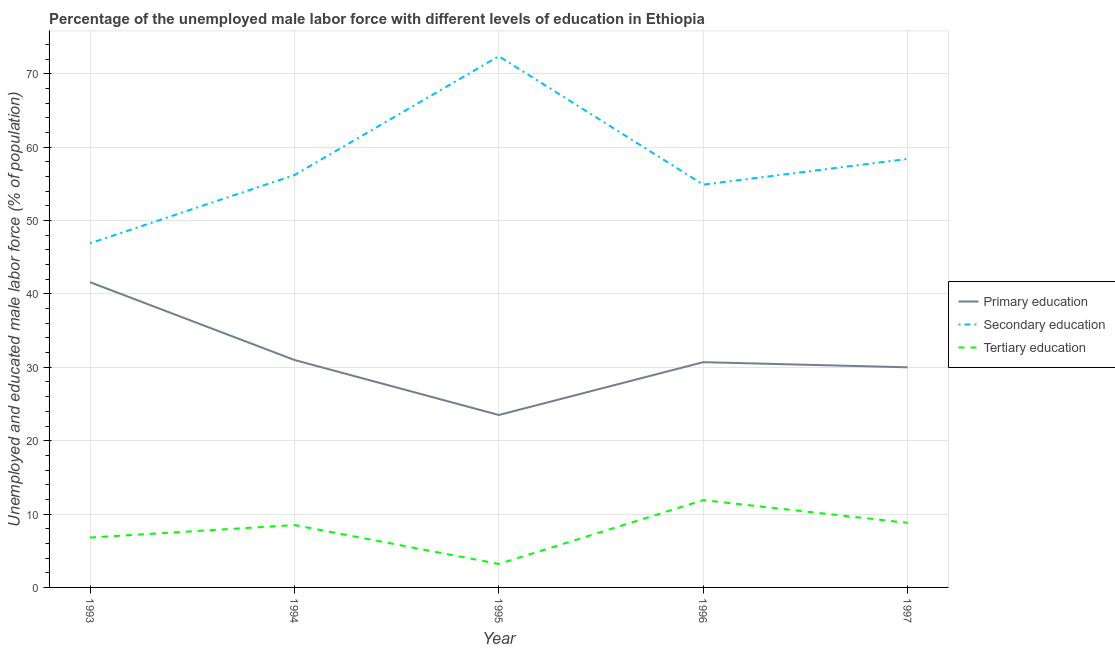Does the line corresponding to percentage of male labor force who received primary education intersect with the line corresponding to percentage of male labor force who received tertiary education?
Ensure brevity in your answer.  No. What is the percentage of male labor force who received secondary education in 1994?
Keep it short and to the point. 56.2. Across all years, what is the maximum percentage of male labor force who received primary education?
Give a very brief answer. 41.6. Across all years, what is the minimum percentage of male labor force who received tertiary education?
Provide a short and direct response. 3.2. In which year was the percentage of male labor force who received primary education maximum?
Give a very brief answer. 1993. What is the total percentage of male labor force who received primary education in the graph?
Keep it short and to the point. 156.8. What is the difference between the percentage of male labor force who received secondary education in 1995 and that in 1997?
Provide a short and direct response. 14. What is the difference between the percentage of male labor force who received primary education in 1997 and the percentage of male labor force who received tertiary education in 1996?
Your answer should be compact. 18.1. What is the average percentage of male labor force who received primary education per year?
Offer a very short reply. 31.36. In the year 1993, what is the difference between the percentage of male labor force who received tertiary education and percentage of male labor force who received secondary education?
Keep it short and to the point. -40.1. In how many years, is the percentage of male labor force who received tertiary education greater than 64 %?
Keep it short and to the point. 0. What is the ratio of the percentage of male labor force who received primary education in 1993 to that in 1996?
Provide a succinct answer. 1.36. Is the percentage of male labor force who received secondary education in 1996 less than that in 1997?
Your answer should be very brief. Yes. What is the difference between the highest and the second highest percentage of male labor force who received secondary education?
Make the answer very short. 14. What is the difference between the highest and the lowest percentage of male labor force who received tertiary education?
Offer a very short reply. 8.7. Is the sum of the percentage of male labor force who received secondary education in 1995 and 1996 greater than the maximum percentage of male labor force who received tertiary education across all years?
Give a very brief answer. Yes. Is the percentage of male labor force who received secondary education strictly greater than the percentage of male labor force who received tertiary education over the years?
Offer a terse response. Yes. Is the percentage of male labor force who received tertiary education strictly less than the percentage of male labor force who received secondary education over the years?
Offer a terse response. Yes. How many lines are there?
Keep it short and to the point. 3. What is the difference between two consecutive major ticks on the Y-axis?
Your answer should be compact. 10. Are the values on the major ticks of Y-axis written in scientific E-notation?
Ensure brevity in your answer.  No. Does the graph contain grids?
Provide a short and direct response. Yes. What is the title of the graph?
Provide a short and direct response. Percentage of the unemployed male labor force with different levels of education in Ethiopia. What is the label or title of the X-axis?
Your answer should be very brief. Year. What is the label or title of the Y-axis?
Provide a succinct answer. Unemployed and educated male labor force (% of population). What is the Unemployed and educated male labor force (% of population) in Primary education in 1993?
Your answer should be compact. 41.6. What is the Unemployed and educated male labor force (% of population) in Secondary education in 1993?
Your response must be concise. 46.9. What is the Unemployed and educated male labor force (% of population) in Tertiary education in 1993?
Your answer should be very brief. 6.8. What is the Unemployed and educated male labor force (% of population) of Secondary education in 1994?
Your response must be concise. 56.2. What is the Unemployed and educated male labor force (% of population) in Secondary education in 1995?
Provide a succinct answer. 72.4. What is the Unemployed and educated male labor force (% of population) in Tertiary education in 1995?
Offer a very short reply. 3.2. What is the Unemployed and educated male labor force (% of population) in Primary education in 1996?
Provide a succinct answer. 30.7. What is the Unemployed and educated male labor force (% of population) in Secondary education in 1996?
Your answer should be compact. 54.9. What is the Unemployed and educated male labor force (% of population) of Tertiary education in 1996?
Your answer should be very brief. 11.9. What is the Unemployed and educated male labor force (% of population) in Primary education in 1997?
Your answer should be very brief. 30. What is the Unemployed and educated male labor force (% of population) of Secondary education in 1997?
Your response must be concise. 58.4. What is the Unemployed and educated male labor force (% of population) of Tertiary education in 1997?
Keep it short and to the point. 8.8. Across all years, what is the maximum Unemployed and educated male labor force (% of population) of Primary education?
Ensure brevity in your answer.  41.6. Across all years, what is the maximum Unemployed and educated male labor force (% of population) of Secondary education?
Your response must be concise. 72.4. Across all years, what is the maximum Unemployed and educated male labor force (% of population) of Tertiary education?
Keep it short and to the point. 11.9. Across all years, what is the minimum Unemployed and educated male labor force (% of population) in Secondary education?
Your answer should be very brief. 46.9. Across all years, what is the minimum Unemployed and educated male labor force (% of population) of Tertiary education?
Offer a very short reply. 3.2. What is the total Unemployed and educated male labor force (% of population) in Primary education in the graph?
Ensure brevity in your answer.  156.8. What is the total Unemployed and educated male labor force (% of population) of Secondary education in the graph?
Ensure brevity in your answer.  288.8. What is the total Unemployed and educated male labor force (% of population) in Tertiary education in the graph?
Offer a very short reply. 39.2. What is the difference between the Unemployed and educated male labor force (% of population) of Primary education in 1993 and that in 1994?
Keep it short and to the point. 10.6. What is the difference between the Unemployed and educated male labor force (% of population) of Secondary education in 1993 and that in 1995?
Provide a short and direct response. -25.5. What is the difference between the Unemployed and educated male labor force (% of population) in Secondary education in 1993 and that in 1996?
Ensure brevity in your answer.  -8. What is the difference between the Unemployed and educated male labor force (% of population) in Tertiary education in 1993 and that in 1996?
Give a very brief answer. -5.1. What is the difference between the Unemployed and educated male labor force (% of population) of Primary education in 1993 and that in 1997?
Give a very brief answer. 11.6. What is the difference between the Unemployed and educated male labor force (% of population) of Secondary education in 1993 and that in 1997?
Provide a short and direct response. -11.5. What is the difference between the Unemployed and educated male labor force (% of population) in Tertiary education in 1993 and that in 1997?
Ensure brevity in your answer.  -2. What is the difference between the Unemployed and educated male labor force (% of population) of Primary education in 1994 and that in 1995?
Ensure brevity in your answer.  7.5. What is the difference between the Unemployed and educated male labor force (% of population) in Secondary education in 1994 and that in 1995?
Keep it short and to the point. -16.2. What is the difference between the Unemployed and educated male labor force (% of population) in Tertiary education in 1994 and that in 1995?
Give a very brief answer. 5.3. What is the difference between the Unemployed and educated male labor force (% of population) in Primary education in 1994 and that in 1996?
Your response must be concise. 0.3. What is the difference between the Unemployed and educated male labor force (% of population) of Tertiary education in 1994 and that in 1996?
Offer a terse response. -3.4. What is the difference between the Unemployed and educated male labor force (% of population) of Secondary education in 1994 and that in 1997?
Your answer should be compact. -2.2. What is the difference between the Unemployed and educated male labor force (% of population) of Tertiary education in 1994 and that in 1997?
Your response must be concise. -0.3. What is the difference between the Unemployed and educated male labor force (% of population) of Primary education in 1995 and that in 1996?
Ensure brevity in your answer.  -7.2. What is the difference between the Unemployed and educated male labor force (% of population) of Tertiary education in 1995 and that in 1996?
Give a very brief answer. -8.7. What is the difference between the Unemployed and educated male labor force (% of population) in Primary education in 1995 and that in 1997?
Keep it short and to the point. -6.5. What is the difference between the Unemployed and educated male labor force (% of population) of Primary education in 1996 and that in 1997?
Give a very brief answer. 0.7. What is the difference between the Unemployed and educated male labor force (% of population) in Secondary education in 1996 and that in 1997?
Ensure brevity in your answer.  -3.5. What is the difference between the Unemployed and educated male labor force (% of population) of Tertiary education in 1996 and that in 1997?
Offer a terse response. 3.1. What is the difference between the Unemployed and educated male labor force (% of population) of Primary education in 1993 and the Unemployed and educated male labor force (% of population) of Secondary education in 1994?
Provide a succinct answer. -14.6. What is the difference between the Unemployed and educated male labor force (% of population) in Primary education in 1993 and the Unemployed and educated male labor force (% of population) in Tertiary education in 1994?
Ensure brevity in your answer.  33.1. What is the difference between the Unemployed and educated male labor force (% of population) in Secondary education in 1993 and the Unemployed and educated male labor force (% of population) in Tertiary education in 1994?
Make the answer very short. 38.4. What is the difference between the Unemployed and educated male labor force (% of population) in Primary education in 1993 and the Unemployed and educated male labor force (% of population) in Secondary education in 1995?
Your answer should be compact. -30.8. What is the difference between the Unemployed and educated male labor force (% of population) in Primary education in 1993 and the Unemployed and educated male labor force (% of population) in Tertiary education in 1995?
Make the answer very short. 38.4. What is the difference between the Unemployed and educated male labor force (% of population) of Secondary education in 1993 and the Unemployed and educated male labor force (% of population) of Tertiary education in 1995?
Your answer should be very brief. 43.7. What is the difference between the Unemployed and educated male labor force (% of population) in Primary education in 1993 and the Unemployed and educated male labor force (% of population) in Secondary education in 1996?
Your answer should be compact. -13.3. What is the difference between the Unemployed and educated male labor force (% of population) in Primary education in 1993 and the Unemployed and educated male labor force (% of population) in Tertiary education in 1996?
Offer a very short reply. 29.7. What is the difference between the Unemployed and educated male labor force (% of population) of Primary education in 1993 and the Unemployed and educated male labor force (% of population) of Secondary education in 1997?
Provide a short and direct response. -16.8. What is the difference between the Unemployed and educated male labor force (% of population) in Primary education in 1993 and the Unemployed and educated male labor force (% of population) in Tertiary education in 1997?
Ensure brevity in your answer.  32.8. What is the difference between the Unemployed and educated male labor force (% of population) of Secondary education in 1993 and the Unemployed and educated male labor force (% of population) of Tertiary education in 1997?
Your answer should be compact. 38.1. What is the difference between the Unemployed and educated male labor force (% of population) in Primary education in 1994 and the Unemployed and educated male labor force (% of population) in Secondary education in 1995?
Ensure brevity in your answer.  -41.4. What is the difference between the Unemployed and educated male labor force (% of population) in Primary education in 1994 and the Unemployed and educated male labor force (% of population) in Tertiary education in 1995?
Your response must be concise. 27.8. What is the difference between the Unemployed and educated male labor force (% of population) of Primary education in 1994 and the Unemployed and educated male labor force (% of population) of Secondary education in 1996?
Your answer should be compact. -23.9. What is the difference between the Unemployed and educated male labor force (% of population) in Secondary education in 1994 and the Unemployed and educated male labor force (% of population) in Tertiary education in 1996?
Offer a very short reply. 44.3. What is the difference between the Unemployed and educated male labor force (% of population) of Primary education in 1994 and the Unemployed and educated male labor force (% of population) of Secondary education in 1997?
Your answer should be compact. -27.4. What is the difference between the Unemployed and educated male labor force (% of population) of Secondary education in 1994 and the Unemployed and educated male labor force (% of population) of Tertiary education in 1997?
Provide a short and direct response. 47.4. What is the difference between the Unemployed and educated male labor force (% of population) of Primary education in 1995 and the Unemployed and educated male labor force (% of population) of Secondary education in 1996?
Your answer should be compact. -31.4. What is the difference between the Unemployed and educated male labor force (% of population) of Secondary education in 1995 and the Unemployed and educated male labor force (% of population) of Tertiary education in 1996?
Make the answer very short. 60.5. What is the difference between the Unemployed and educated male labor force (% of population) in Primary education in 1995 and the Unemployed and educated male labor force (% of population) in Secondary education in 1997?
Your response must be concise. -34.9. What is the difference between the Unemployed and educated male labor force (% of population) of Secondary education in 1995 and the Unemployed and educated male labor force (% of population) of Tertiary education in 1997?
Provide a succinct answer. 63.6. What is the difference between the Unemployed and educated male labor force (% of population) in Primary education in 1996 and the Unemployed and educated male labor force (% of population) in Secondary education in 1997?
Your response must be concise. -27.7. What is the difference between the Unemployed and educated male labor force (% of population) in Primary education in 1996 and the Unemployed and educated male labor force (% of population) in Tertiary education in 1997?
Provide a short and direct response. 21.9. What is the difference between the Unemployed and educated male labor force (% of population) in Secondary education in 1996 and the Unemployed and educated male labor force (% of population) in Tertiary education in 1997?
Your answer should be compact. 46.1. What is the average Unemployed and educated male labor force (% of population) in Primary education per year?
Offer a terse response. 31.36. What is the average Unemployed and educated male labor force (% of population) of Secondary education per year?
Your answer should be compact. 57.76. What is the average Unemployed and educated male labor force (% of population) in Tertiary education per year?
Give a very brief answer. 7.84. In the year 1993, what is the difference between the Unemployed and educated male labor force (% of population) of Primary education and Unemployed and educated male labor force (% of population) of Secondary education?
Ensure brevity in your answer.  -5.3. In the year 1993, what is the difference between the Unemployed and educated male labor force (% of population) in Primary education and Unemployed and educated male labor force (% of population) in Tertiary education?
Provide a short and direct response. 34.8. In the year 1993, what is the difference between the Unemployed and educated male labor force (% of population) in Secondary education and Unemployed and educated male labor force (% of population) in Tertiary education?
Provide a succinct answer. 40.1. In the year 1994, what is the difference between the Unemployed and educated male labor force (% of population) in Primary education and Unemployed and educated male labor force (% of population) in Secondary education?
Offer a very short reply. -25.2. In the year 1994, what is the difference between the Unemployed and educated male labor force (% of population) in Secondary education and Unemployed and educated male labor force (% of population) in Tertiary education?
Provide a succinct answer. 47.7. In the year 1995, what is the difference between the Unemployed and educated male labor force (% of population) of Primary education and Unemployed and educated male labor force (% of population) of Secondary education?
Offer a terse response. -48.9. In the year 1995, what is the difference between the Unemployed and educated male labor force (% of population) of Primary education and Unemployed and educated male labor force (% of population) of Tertiary education?
Ensure brevity in your answer.  20.3. In the year 1995, what is the difference between the Unemployed and educated male labor force (% of population) in Secondary education and Unemployed and educated male labor force (% of population) in Tertiary education?
Make the answer very short. 69.2. In the year 1996, what is the difference between the Unemployed and educated male labor force (% of population) in Primary education and Unemployed and educated male labor force (% of population) in Secondary education?
Provide a short and direct response. -24.2. In the year 1996, what is the difference between the Unemployed and educated male labor force (% of population) in Primary education and Unemployed and educated male labor force (% of population) in Tertiary education?
Ensure brevity in your answer.  18.8. In the year 1996, what is the difference between the Unemployed and educated male labor force (% of population) of Secondary education and Unemployed and educated male labor force (% of population) of Tertiary education?
Your answer should be very brief. 43. In the year 1997, what is the difference between the Unemployed and educated male labor force (% of population) of Primary education and Unemployed and educated male labor force (% of population) of Secondary education?
Give a very brief answer. -28.4. In the year 1997, what is the difference between the Unemployed and educated male labor force (% of population) in Primary education and Unemployed and educated male labor force (% of population) in Tertiary education?
Your answer should be compact. 21.2. In the year 1997, what is the difference between the Unemployed and educated male labor force (% of population) of Secondary education and Unemployed and educated male labor force (% of population) of Tertiary education?
Your answer should be compact. 49.6. What is the ratio of the Unemployed and educated male labor force (% of population) in Primary education in 1993 to that in 1994?
Keep it short and to the point. 1.34. What is the ratio of the Unemployed and educated male labor force (% of population) of Secondary education in 1993 to that in 1994?
Offer a very short reply. 0.83. What is the ratio of the Unemployed and educated male labor force (% of population) of Tertiary education in 1993 to that in 1994?
Keep it short and to the point. 0.8. What is the ratio of the Unemployed and educated male labor force (% of population) in Primary education in 1993 to that in 1995?
Make the answer very short. 1.77. What is the ratio of the Unemployed and educated male labor force (% of population) of Secondary education in 1993 to that in 1995?
Offer a terse response. 0.65. What is the ratio of the Unemployed and educated male labor force (% of population) in Tertiary education in 1993 to that in 1995?
Provide a succinct answer. 2.12. What is the ratio of the Unemployed and educated male labor force (% of population) in Primary education in 1993 to that in 1996?
Keep it short and to the point. 1.35. What is the ratio of the Unemployed and educated male labor force (% of population) in Secondary education in 1993 to that in 1996?
Make the answer very short. 0.85. What is the ratio of the Unemployed and educated male labor force (% of population) of Primary education in 1993 to that in 1997?
Give a very brief answer. 1.39. What is the ratio of the Unemployed and educated male labor force (% of population) in Secondary education in 1993 to that in 1997?
Provide a short and direct response. 0.8. What is the ratio of the Unemployed and educated male labor force (% of population) in Tertiary education in 1993 to that in 1997?
Provide a succinct answer. 0.77. What is the ratio of the Unemployed and educated male labor force (% of population) in Primary education in 1994 to that in 1995?
Offer a terse response. 1.32. What is the ratio of the Unemployed and educated male labor force (% of population) of Secondary education in 1994 to that in 1995?
Keep it short and to the point. 0.78. What is the ratio of the Unemployed and educated male labor force (% of population) of Tertiary education in 1994 to that in 1995?
Your response must be concise. 2.66. What is the ratio of the Unemployed and educated male labor force (% of population) of Primary education in 1994 to that in 1996?
Your answer should be very brief. 1.01. What is the ratio of the Unemployed and educated male labor force (% of population) of Secondary education in 1994 to that in 1996?
Offer a terse response. 1.02. What is the ratio of the Unemployed and educated male labor force (% of population) in Tertiary education in 1994 to that in 1996?
Your response must be concise. 0.71. What is the ratio of the Unemployed and educated male labor force (% of population) in Secondary education in 1994 to that in 1997?
Offer a terse response. 0.96. What is the ratio of the Unemployed and educated male labor force (% of population) of Tertiary education in 1994 to that in 1997?
Offer a very short reply. 0.97. What is the ratio of the Unemployed and educated male labor force (% of population) in Primary education in 1995 to that in 1996?
Ensure brevity in your answer.  0.77. What is the ratio of the Unemployed and educated male labor force (% of population) in Secondary education in 1995 to that in 1996?
Provide a succinct answer. 1.32. What is the ratio of the Unemployed and educated male labor force (% of population) in Tertiary education in 1995 to that in 1996?
Make the answer very short. 0.27. What is the ratio of the Unemployed and educated male labor force (% of population) in Primary education in 1995 to that in 1997?
Provide a succinct answer. 0.78. What is the ratio of the Unemployed and educated male labor force (% of population) of Secondary education in 1995 to that in 1997?
Ensure brevity in your answer.  1.24. What is the ratio of the Unemployed and educated male labor force (% of population) of Tertiary education in 1995 to that in 1997?
Make the answer very short. 0.36. What is the ratio of the Unemployed and educated male labor force (% of population) of Primary education in 1996 to that in 1997?
Your answer should be compact. 1.02. What is the ratio of the Unemployed and educated male labor force (% of population) in Secondary education in 1996 to that in 1997?
Provide a short and direct response. 0.94. What is the ratio of the Unemployed and educated male labor force (% of population) in Tertiary education in 1996 to that in 1997?
Offer a terse response. 1.35. What is the difference between the highest and the second highest Unemployed and educated male labor force (% of population) in Secondary education?
Your answer should be compact. 14. What is the difference between the highest and the second highest Unemployed and educated male labor force (% of population) in Tertiary education?
Your answer should be compact. 3.1. What is the difference between the highest and the lowest Unemployed and educated male labor force (% of population) of Tertiary education?
Ensure brevity in your answer.  8.7. 